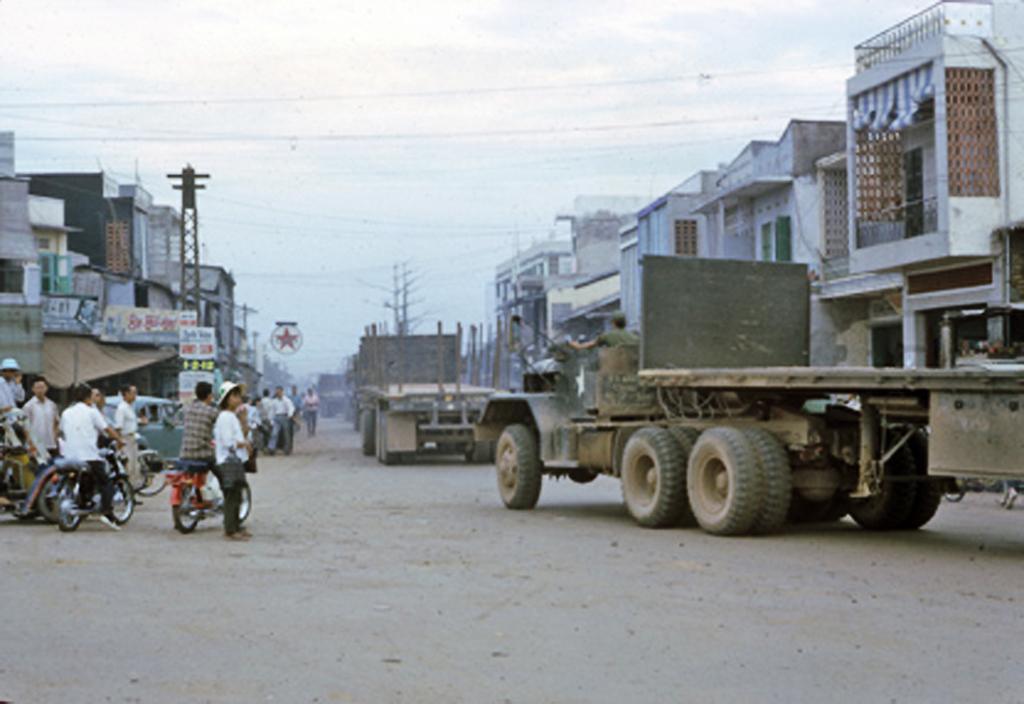Could you give a brief overview of what you see in this image? In this image there are few vehicles and few are riding a bike and few are standing on the road. On the right and left side of the image there are buildings. In the background there is a sky. 